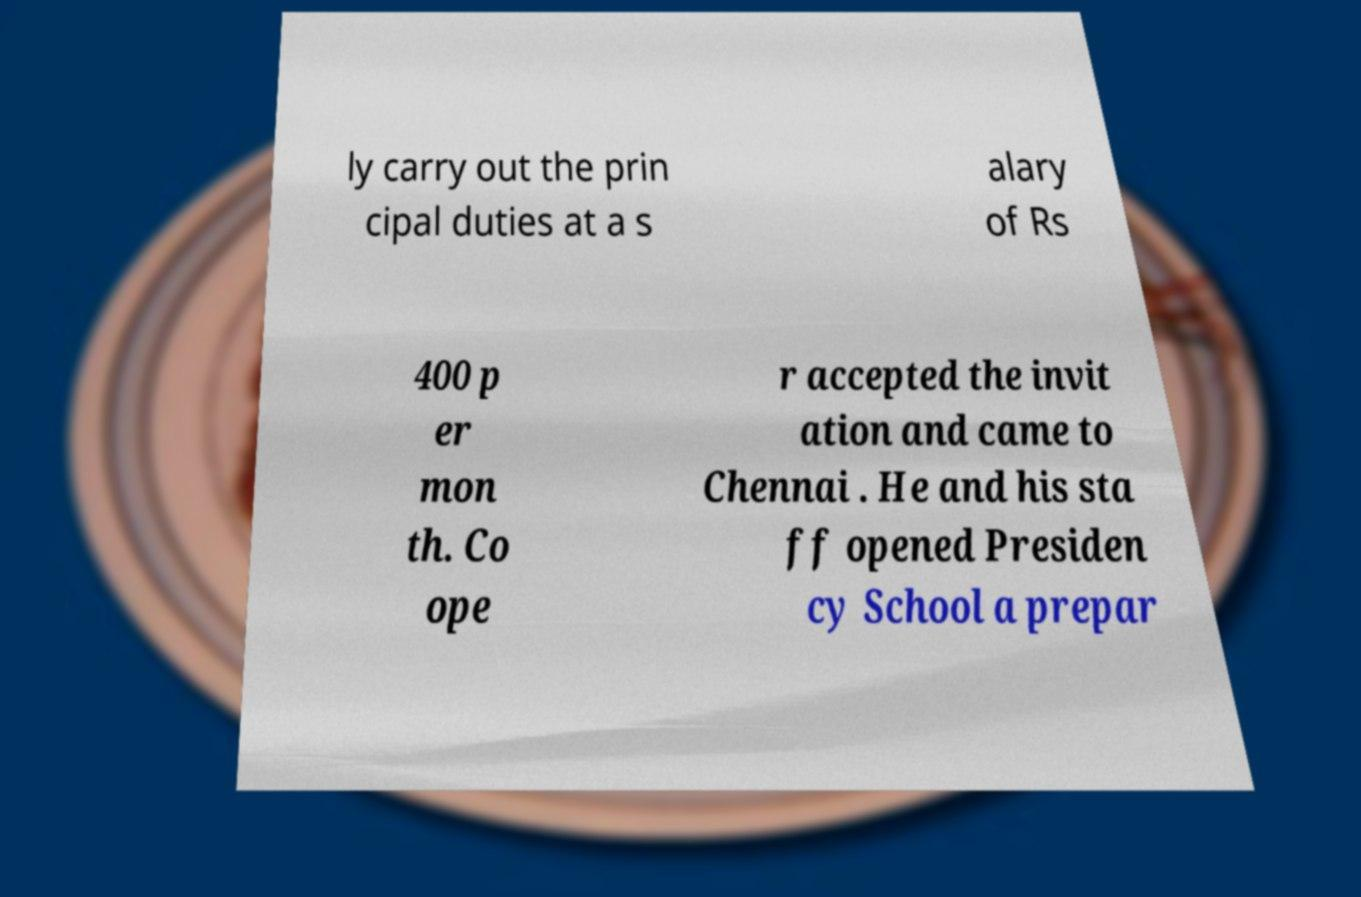Can you read and provide the text displayed in the image?This photo seems to have some interesting text. Can you extract and type it out for me? ly carry out the prin cipal duties at a s alary of Rs 400 p er mon th. Co ope r accepted the invit ation and came to Chennai . He and his sta ff opened Presiden cy School a prepar 